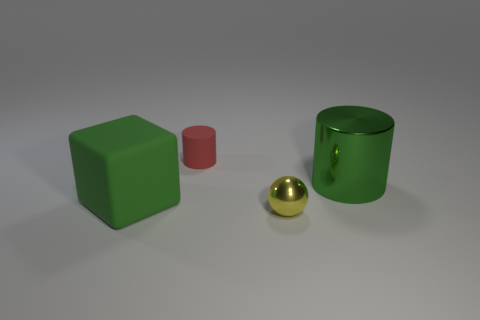Add 2 green cylinders. How many objects exist? 6 Subtract all blocks. How many objects are left? 3 Subtract 1 yellow balls. How many objects are left? 3 Subtract all metal things. Subtract all small metallic balls. How many objects are left? 1 Add 4 rubber cylinders. How many rubber cylinders are left? 5 Add 1 large matte blocks. How many large matte blocks exist? 2 